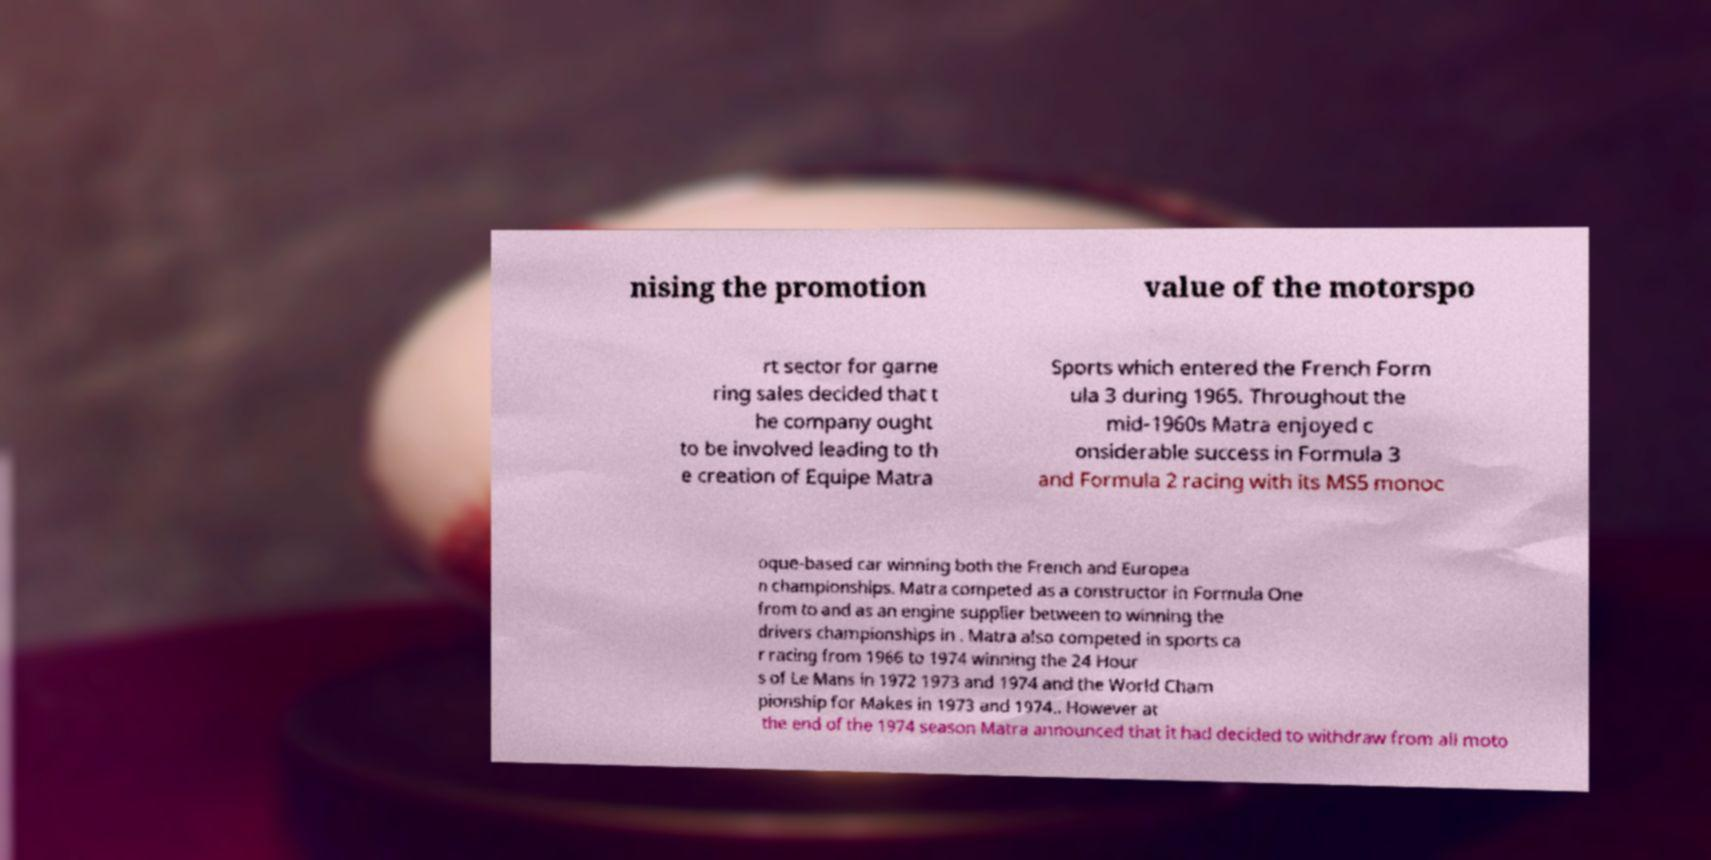Can you accurately transcribe the text from the provided image for me? nising the promotion value of the motorspo rt sector for garne ring sales decided that t he company ought to be involved leading to th e creation of Equipe Matra Sports which entered the French Form ula 3 during 1965. Throughout the mid-1960s Matra enjoyed c onsiderable success in Formula 3 and Formula 2 racing with its MS5 monoc oque-based car winning both the French and Europea n championships. Matra competed as a constructor in Formula One from to and as an engine supplier between to winning the drivers championships in . Matra also competed in sports ca r racing from 1966 to 1974 winning the 24 Hour s of Le Mans in 1972 1973 and 1974 and the World Cham pionship for Makes in 1973 and 1974.. However at the end of the 1974 season Matra announced that it had decided to withdraw from all moto 